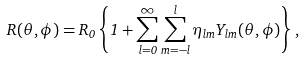Convert formula to latex. <formula><loc_0><loc_0><loc_500><loc_500>R ( \theta , \phi ) = R _ { 0 } \left \{ 1 + \sum _ { l = 0 } ^ { \infty } \sum _ { m = - l } ^ { l } \eta _ { l m } Y _ { l m } ( \theta , \phi ) \right \} ,</formula> 